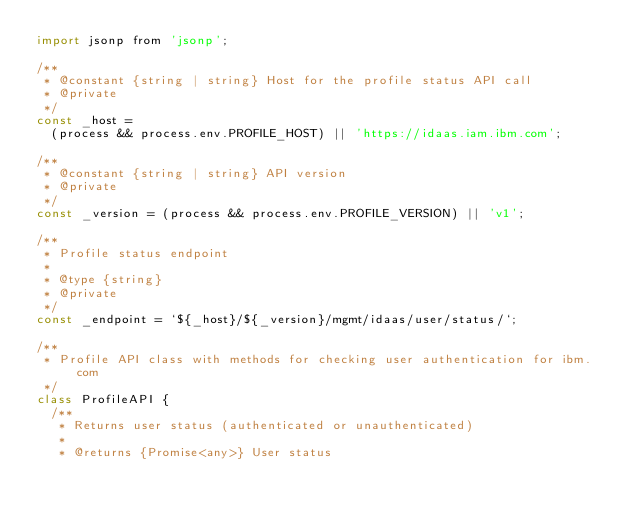<code> <loc_0><loc_0><loc_500><loc_500><_JavaScript_>import jsonp from 'jsonp';

/**
 * @constant {string | string} Host for the profile status API call
 * @private
 */
const _host =
  (process && process.env.PROFILE_HOST) || 'https://idaas.iam.ibm.com';

/**
 * @constant {string | string} API version
 * @private
 */
const _version = (process && process.env.PROFILE_VERSION) || 'v1';

/**
 * Profile status endpoint
 *
 * @type {string}
 * @private
 */
const _endpoint = `${_host}/${_version}/mgmt/idaas/user/status/`;

/**
 * Profile API class with methods for checking user authentication for ibm.com
 */
class ProfileAPI {
  /**
   * Returns user status (authenticated or unauthenticated)
   *
   * @returns {Promise<any>} User status</code> 